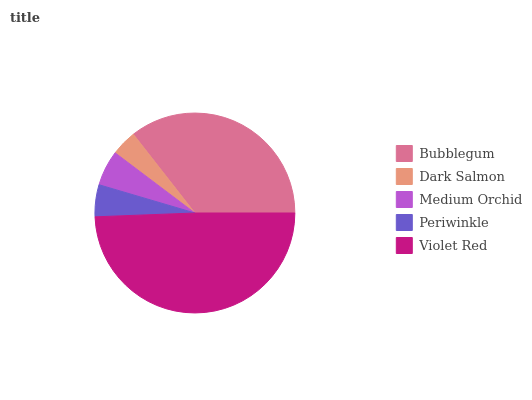Is Dark Salmon the minimum?
Answer yes or no. Yes. Is Violet Red the maximum?
Answer yes or no. Yes. Is Medium Orchid the minimum?
Answer yes or no. No. Is Medium Orchid the maximum?
Answer yes or no. No. Is Medium Orchid greater than Dark Salmon?
Answer yes or no. Yes. Is Dark Salmon less than Medium Orchid?
Answer yes or no. Yes. Is Dark Salmon greater than Medium Orchid?
Answer yes or no. No. Is Medium Orchid less than Dark Salmon?
Answer yes or no. No. Is Medium Orchid the high median?
Answer yes or no. Yes. Is Medium Orchid the low median?
Answer yes or no. Yes. Is Violet Red the high median?
Answer yes or no. No. Is Bubblegum the low median?
Answer yes or no. No. 